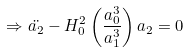<formula> <loc_0><loc_0><loc_500><loc_500>\Rightarrow \ddot { a _ { 2 } } - H _ { 0 } ^ { 2 } \left ( \frac { a _ { 0 } ^ { 3 } } { a _ { 1 } ^ { 3 } } \right ) a _ { 2 } = 0</formula> 